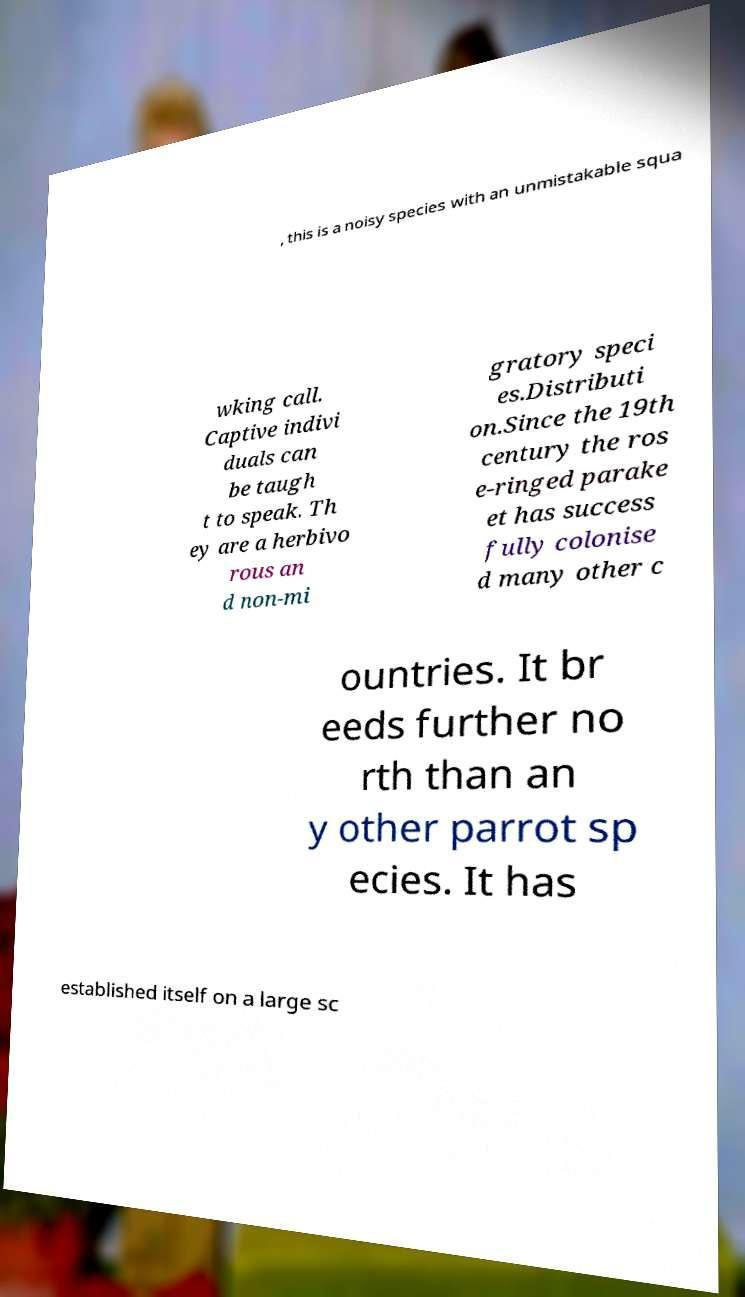Can you accurately transcribe the text from the provided image for me? , this is a noisy species with an unmistakable squa wking call. Captive indivi duals can be taugh t to speak. Th ey are a herbivo rous an d non-mi gratory speci es.Distributi on.Since the 19th century the ros e-ringed parake et has success fully colonise d many other c ountries. It br eeds further no rth than an y other parrot sp ecies. It has established itself on a large sc 